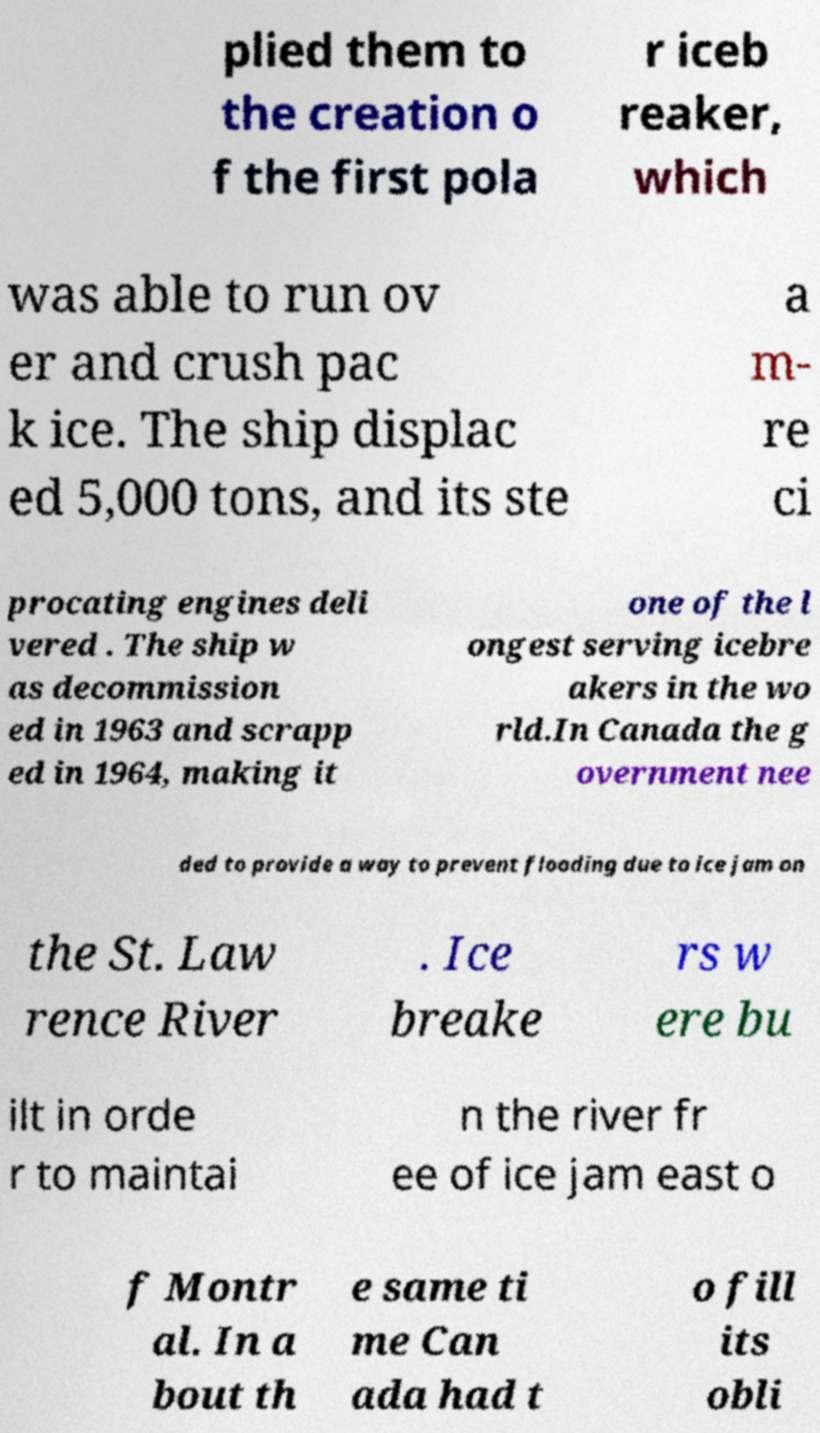Could you assist in decoding the text presented in this image and type it out clearly? plied them to the creation o f the first pola r iceb reaker, which was able to run ov er and crush pac k ice. The ship displac ed 5,000 tons, and its ste a m- re ci procating engines deli vered . The ship w as decommission ed in 1963 and scrapp ed in 1964, making it one of the l ongest serving icebre akers in the wo rld.In Canada the g overnment nee ded to provide a way to prevent flooding due to ice jam on the St. Law rence River . Ice breake rs w ere bu ilt in orde r to maintai n the river fr ee of ice jam east o f Montr al. In a bout th e same ti me Can ada had t o fill its obli 